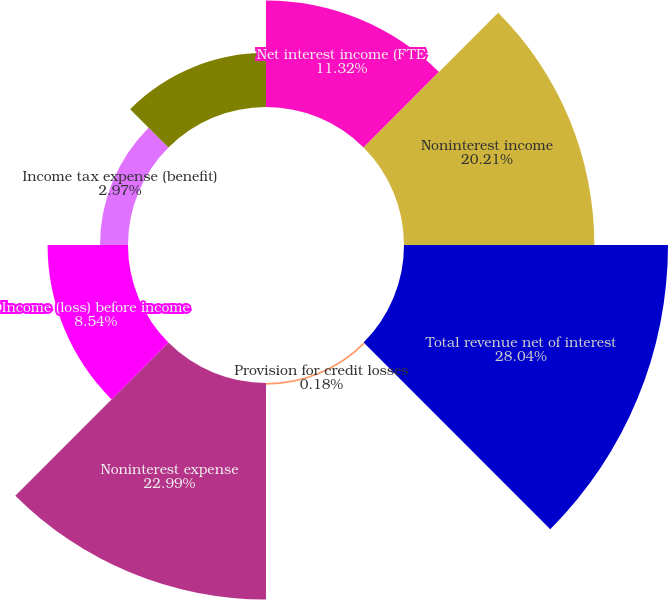Convert chart. <chart><loc_0><loc_0><loc_500><loc_500><pie_chart><fcel>Net interest income (FTE<fcel>Noninterest income<fcel>Total revenue net of interest<fcel>Provision for credit losses<fcel>Noninterest expense<fcel>Income (loss) before income<fcel>Income tax expense (benefit)<fcel>Net income (loss)<nl><fcel>11.32%<fcel>20.21%<fcel>28.03%<fcel>0.18%<fcel>22.99%<fcel>8.54%<fcel>2.97%<fcel>5.75%<nl></chart> 